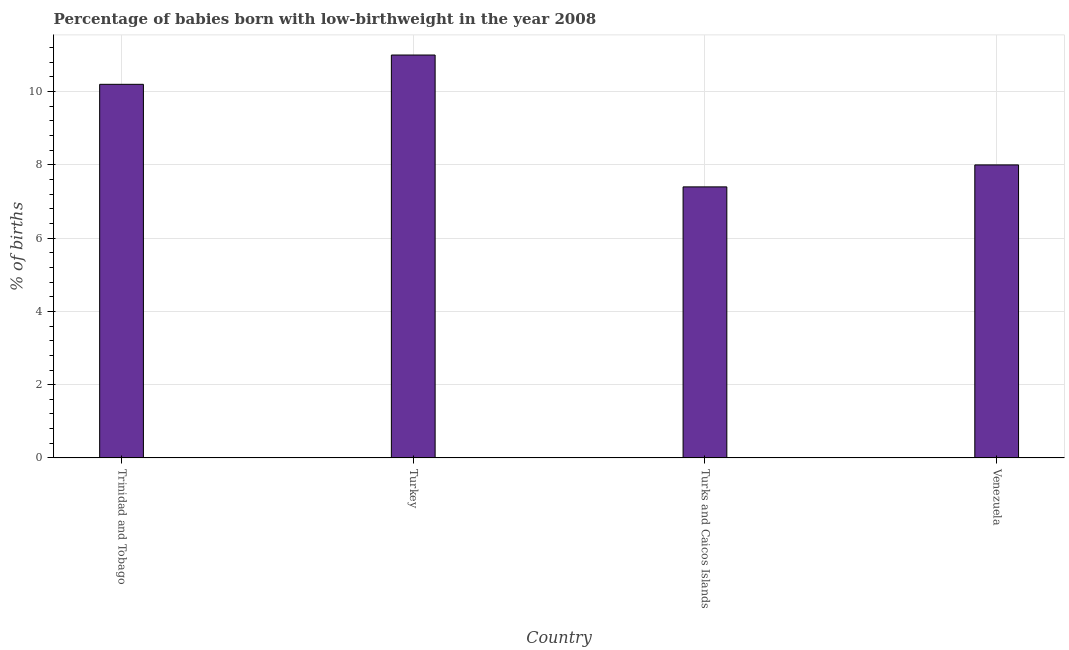Does the graph contain any zero values?
Keep it short and to the point. No. What is the title of the graph?
Ensure brevity in your answer.  Percentage of babies born with low-birthweight in the year 2008. What is the label or title of the Y-axis?
Your answer should be compact. % of births. What is the percentage of babies who were born with low-birthweight in Turks and Caicos Islands?
Offer a terse response. 7.4. Across all countries, what is the maximum percentage of babies who were born with low-birthweight?
Your response must be concise. 11. Across all countries, what is the minimum percentage of babies who were born with low-birthweight?
Your answer should be compact. 7.4. In which country was the percentage of babies who were born with low-birthweight maximum?
Provide a succinct answer. Turkey. In which country was the percentage of babies who were born with low-birthweight minimum?
Provide a succinct answer. Turks and Caicos Islands. What is the sum of the percentage of babies who were born with low-birthweight?
Your response must be concise. 36.6. What is the difference between the percentage of babies who were born with low-birthweight in Trinidad and Tobago and Venezuela?
Give a very brief answer. 2.2. What is the average percentage of babies who were born with low-birthweight per country?
Your response must be concise. 9.15. What is the ratio of the percentage of babies who were born with low-birthweight in Turkey to that in Venezuela?
Give a very brief answer. 1.38. What is the difference between the highest and the second highest percentage of babies who were born with low-birthweight?
Offer a very short reply. 0.8. How many bars are there?
Provide a succinct answer. 4. Are all the bars in the graph horizontal?
Give a very brief answer. No. Are the values on the major ticks of Y-axis written in scientific E-notation?
Give a very brief answer. No. What is the % of births in Trinidad and Tobago?
Your response must be concise. 10.2. What is the % of births of Turkey?
Offer a terse response. 11. What is the difference between the % of births in Trinidad and Tobago and Turkey?
Give a very brief answer. -0.8. What is the difference between the % of births in Turkey and Venezuela?
Provide a short and direct response. 3. What is the difference between the % of births in Turks and Caicos Islands and Venezuela?
Provide a short and direct response. -0.6. What is the ratio of the % of births in Trinidad and Tobago to that in Turkey?
Your response must be concise. 0.93. What is the ratio of the % of births in Trinidad and Tobago to that in Turks and Caicos Islands?
Your answer should be very brief. 1.38. What is the ratio of the % of births in Trinidad and Tobago to that in Venezuela?
Provide a short and direct response. 1.27. What is the ratio of the % of births in Turkey to that in Turks and Caicos Islands?
Your answer should be compact. 1.49. What is the ratio of the % of births in Turkey to that in Venezuela?
Offer a very short reply. 1.38. What is the ratio of the % of births in Turks and Caicos Islands to that in Venezuela?
Provide a short and direct response. 0.93. 